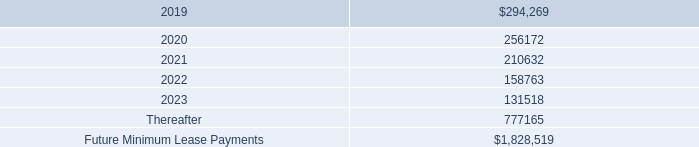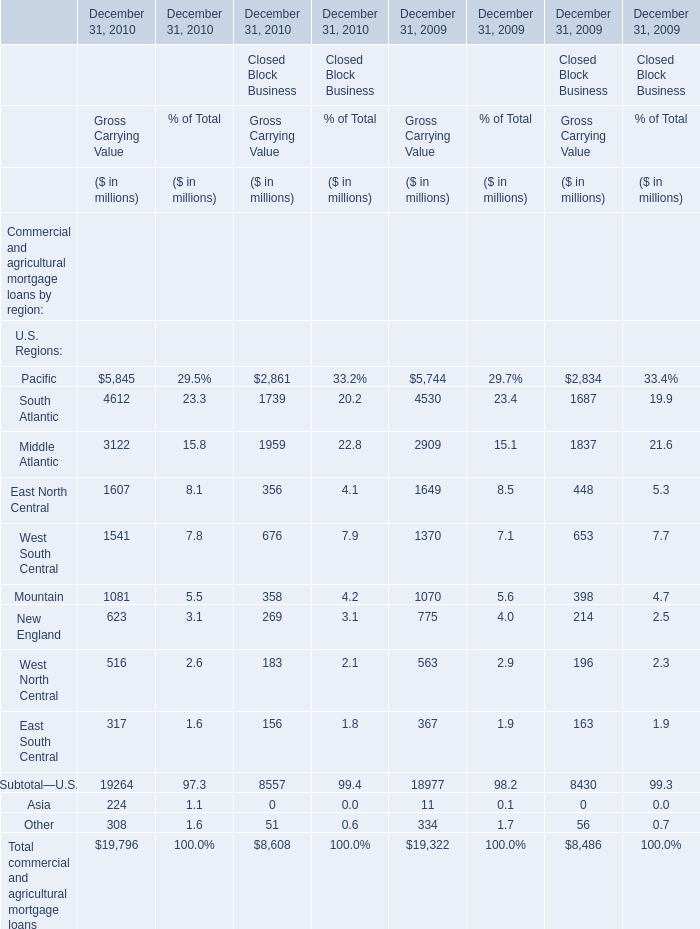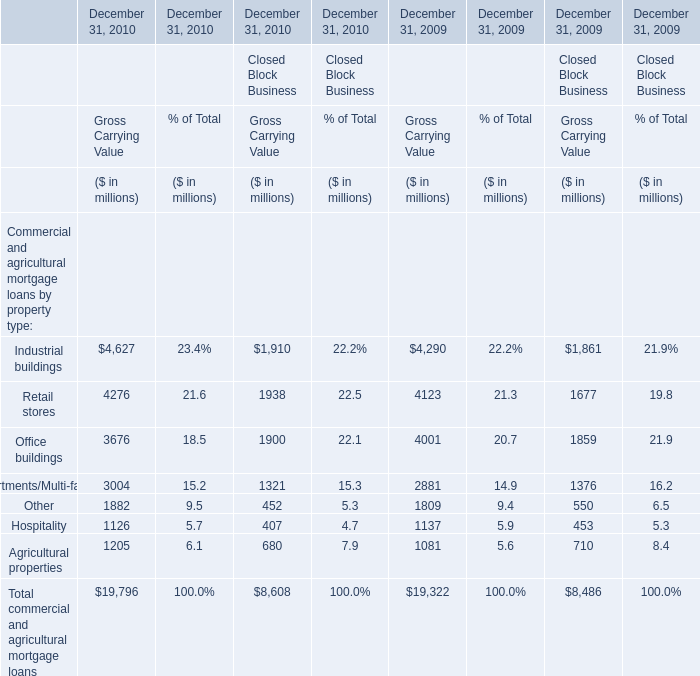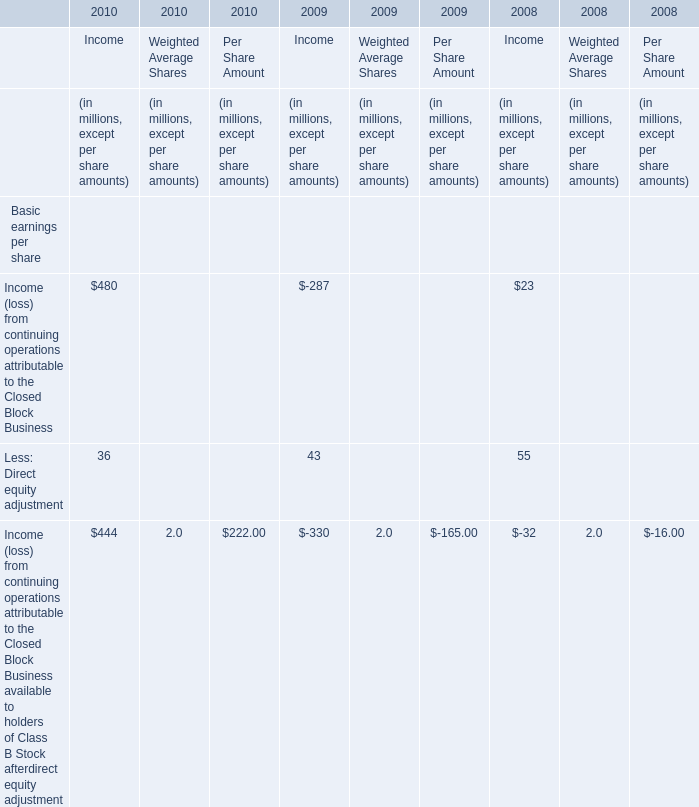What's the growth rate of the Gross Carrying Value in terms of Financial Services Businesses for Commercial and agricultural mortgage loans by property type:Retail stores on December 31 in 2010? 
Computations: ((4276 - 4123) / 4123)
Answer: 0.03711. what was the cumulative total rental expense for operating leases from 2016 to 2018 
Computations: (212 + (300 + 247))
Answer: 759.0. 